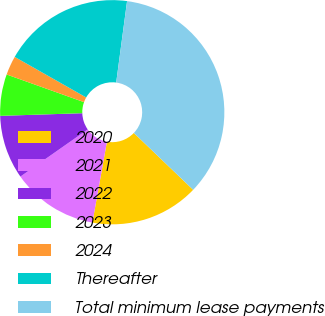Convert chart. <chart><loc_0><loc_0><loc_500><loc_500><pie_chart><fcel>2020<fcel>2021<fcel>2022<fcel>2023<fcel>2024<fcel>Thereafter<fcel>Total minimum lease payments<nl><fcel>15.67%<fcel>12.44%<fcel>9.21%<fcel>5.98%<fcel>2.75%<fcel>18.9%<fcel>35.05%<nl></chart> 